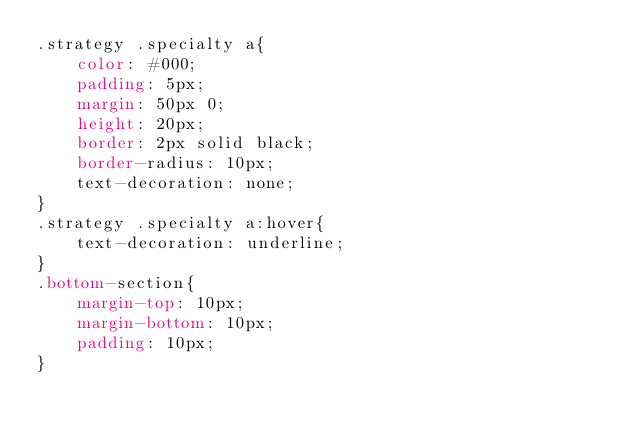Convert code to text. <code><loc_0><loc_0><loc_500><loc_500><_CSS_>.strategy .specialty a{
    color: #000;
    padding: 5px;
    margin: 50px 0;
    height: 20px; 
    border: 2px solid black;
    border-radius: 10px;
    text-decoration: none;
}
.strategy .specialty a:hover{
    text-decoration: underline;
}
.bottom-section{
    margin-top: 10px;
    margin-bottom: 10px;
    padding: 10px;
}</code> 